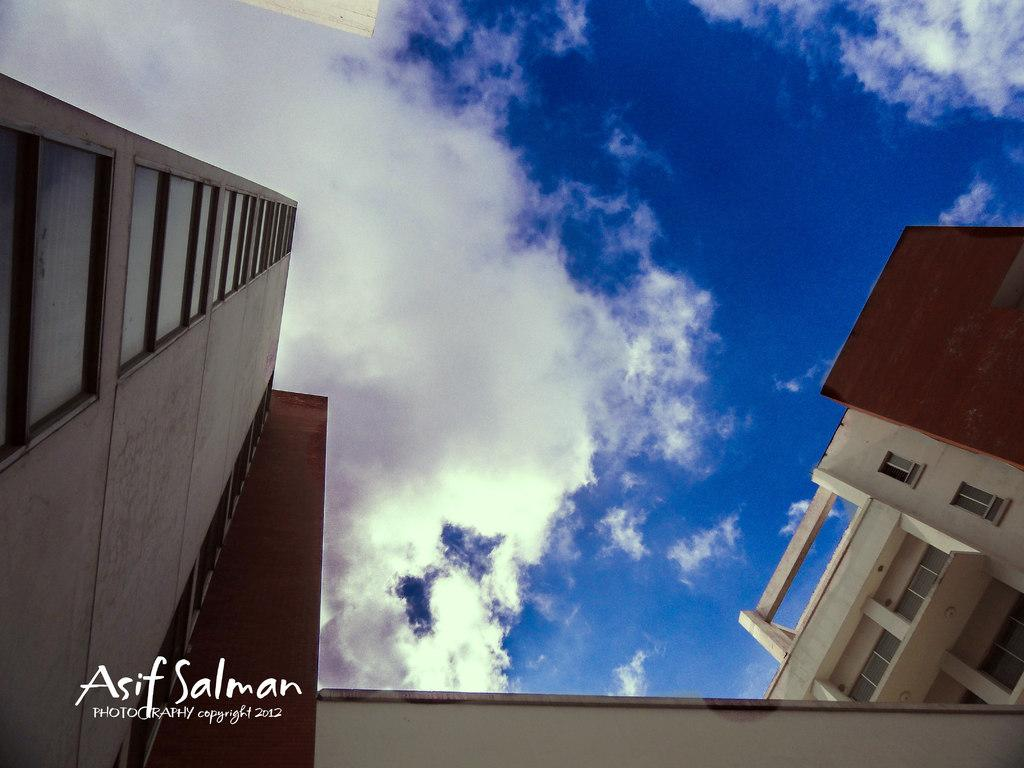What type of structure is visible in the image? There is a building with windows in the image. What can be seen in the background of the image? The sky is visible in the background of the image. Is there any additional information about the image itself? Yes, there is a watermark on the image. What type of liquid is being used for the activity in the image? There is no activity or liquid present in the image; it features a building with windows and a visible sky in the background. 